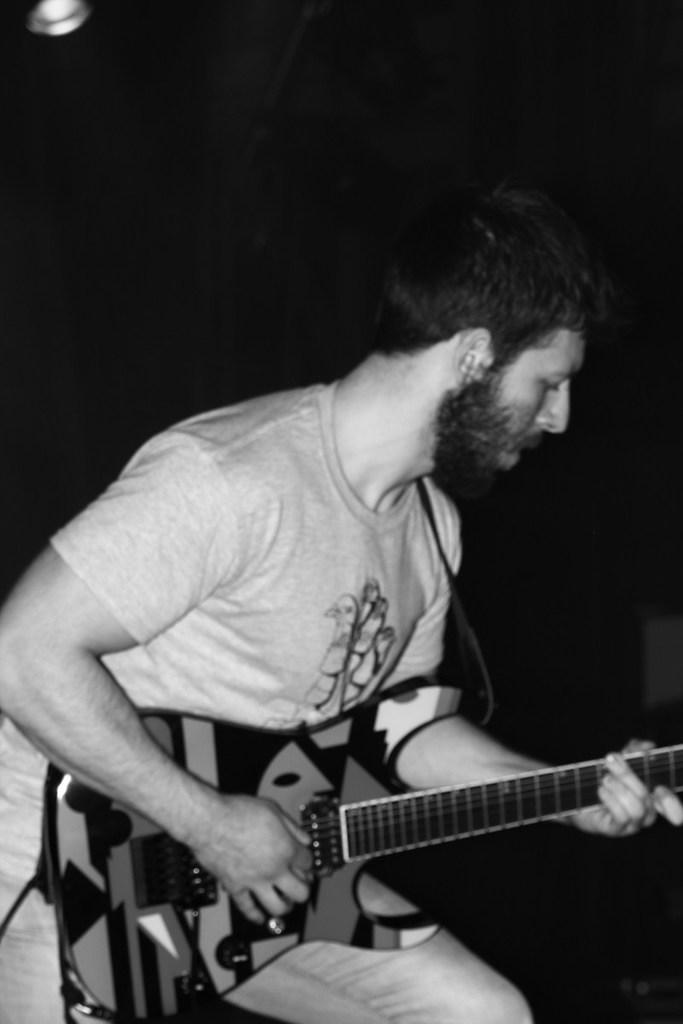Who is present in the image? There is a person in the image. What is the person doing in the image? The person is sitting and playing a guitar. What type of berry is the person shaking in the image? There is no berry or shaking action present in the image; the person is playing a guitar while sitting. 